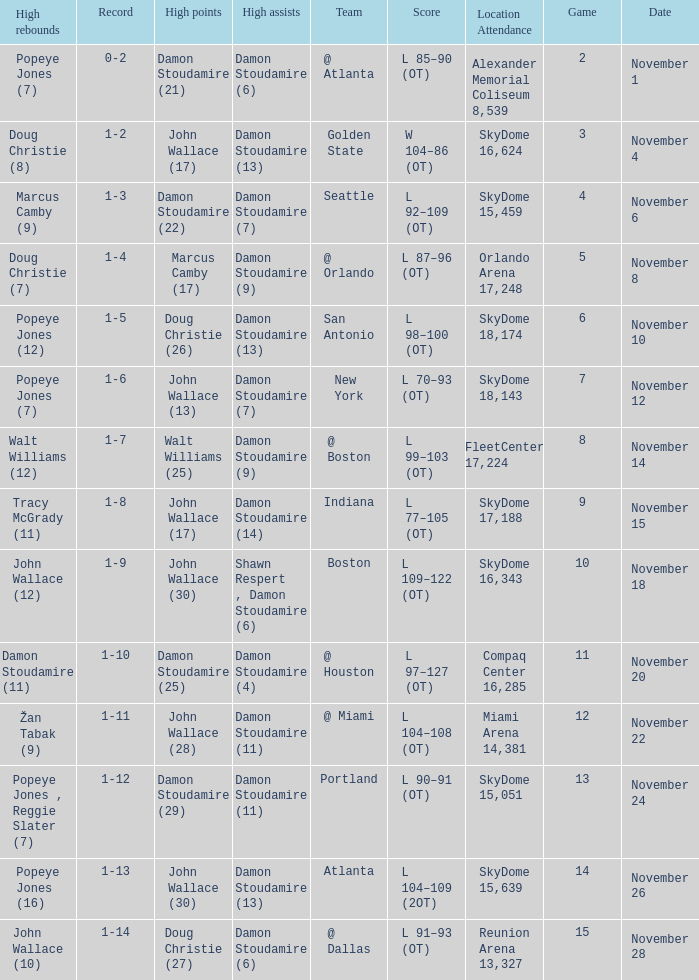How many games did the team play when they were 1-3? 1.0. I'm looking to parse the entire table for insights. Could you assist me with that? {'header': ['High rebounds', 'Record', 'High points', 'High assists', 'Team', 'Score', 'Location Attendance', 'Game', 'Date'], 'rows': [['Popeye Jones (7)', '0-2', 'Damon Stoudamire (21)', 'Damon Stoudamire (6)', '@ Atlanta', 'L 85–90 (OT)', 'Alexander Memorial Coliseum 8,539', '2', 'November 1'], ['Doug Christie (8)', '1-2', 'John Wallace (17)', 'Damon Stoudamire (13)', 'Golden State', 'W 104–86 (OT)', 'SkyDome 16,624', '3', 'November 4'], ['Marcus Camby (9)', '1-3', 'Damon Stoudamire (22)', 'Damon Stoudamire (7)', 'Seattle', 'L 92–109 (OT)', 'SkyDome 15,459', '4', 'November 6'], ['Doug Christie (7)', '1-4', 'Marcus Camby (17)', 'Damon Stoudamire (9)', '@ Orlando', 'L 87–96 (OT)', 'Orlando Arena 17,248', '5', 'November 8'], ['Popeye Jones (12)', '1-5', 'Doug Christie (26)', 'Damon Stoudamire (13)', 'San Antonio', 'L 98–100 (OT)', 'SkyDome 18,174', '6', 'November 10'], ['Popeye Jones (7)', '1-6', 'John Wallace (13)', 'Damon Stoudamire (7)', 'New York', 'L 70–93 (OT)', 'SkyDome 18,143', '7', 'November 12'], ['Walt Williams (12)', '1-7', 'Walt Williams (25)', 'Damon Stoudamire (9)', '@ Boston', 'L 99–103 (OT)', 'FleetCenter 17,224', '8', 'November 14'], ['Tracy McGrady (11)', '1-8', 'John Wallace (17)', 'Damon Stoudamire (14)', 'Indiana', 'L 77–105 (OT)', 'SkyDome 17,188', '9', 'November 15'], ['John Wallace (12)', '1-9', 'John Wallace (30)', 'Shawn Respert , Damon Stoudamire (6)', 'Boston', 'L 109–122 (OT)', 'SkyDome 16,343', '10', 'November 18'], ['Damon Stoudamire (11)', '1-10', 'Damon Stoudamire (25)', 'Damon Stoudamire (4)', '@ Houston', 'L 97–127 (OT)', 'Compaq Center 16,285', '11', 'November 20'], ['Žan Tabak (9)', '1-11', 'John Wallace (28)', 'Damon Stoudamire (11)', '@ Miami', 'L 104–108 (OT)', 'Miami Arena 14,381', '12', 'November 22'], ['Popeye Jones , Reggie Slater (7)', '1-12', 'Damon Stoudamire (29)', 'Damon Stoudamire (11)', 'Portland', 'L 90–91 (OT)', 'SkyDome 15,051', '13', 'November 24'], ['Popeye Jones (16)', '1-13', 'John Wallace (30)', 'Damon Stoudamire (13)', 'Atlanta', 'L 104–109 (2OT)', 'SkyDome 15,639', '14', 'November 26'], ['John Wallace (10)', '1-14', 'Doug Christie (27)', 'Damon Stoudamire (6)', '@ Dallas', 'L 91–93 (OT)', 'Reunion Arena 13,327', '15', 'November 28']]} 